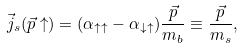Convert formula to latex. <formula><loc_0><loc_0><loc_500><loc_500>\vec { j } _ { s } ( \vec { p } \uparrow ) = ( \alpha _ { \uparrow \uparrow } - \alpha _ { \downarrow \uparrow } ) \frac { \vec { p } } { m _ { b } } \equiv \frac { \vec { p } } { m _ { s } } ,</formula> 